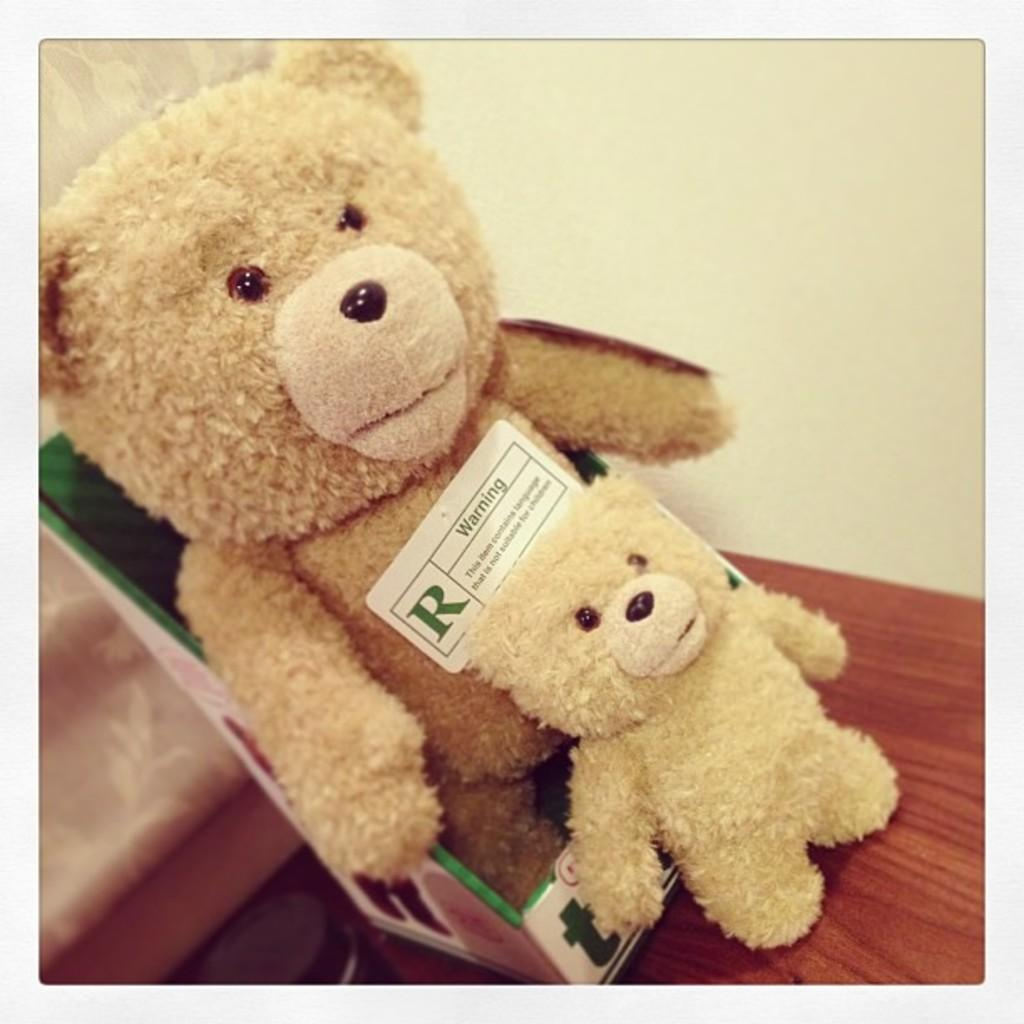What is on top of the box in the image? There is a teddy bear on a box in the image. What is on the table in the image? There is a small teddy bear on a table in the image. What can be seen hanging in the background of the image? There is a curtain in the image. What is visible behind the curtain in the image? There is a wall in the image. What type of bubble can be seen floating near the teddy bear on the table? There is no bubble present in the image; it only features teddy bears on a box and table, a curtain, and a wall. 